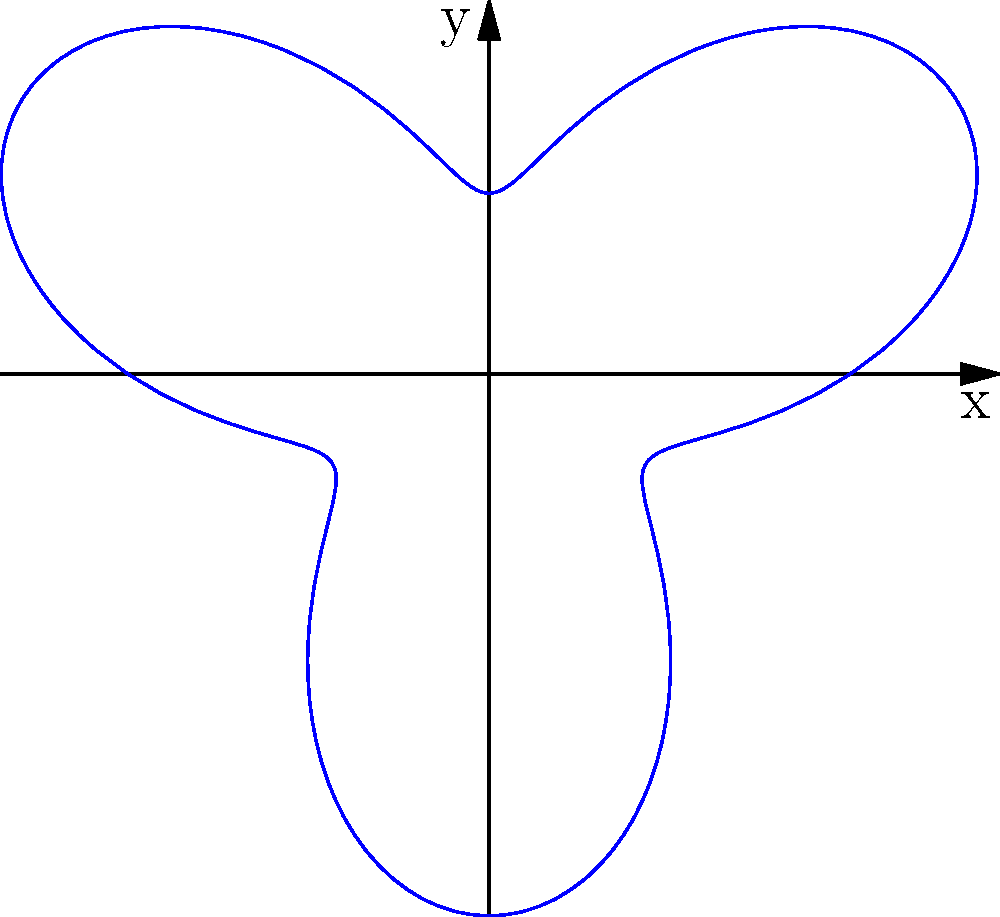As an organic farmer, you're analyzing a new pesticide spray pattern for your crops. The coverage is represented by the polar curve $r = 2 + \sin(3\theta)$. What is the maximum radial distance the spray reaches from the nozzle? To find the maximum radial distance, we need to follow these steps:

1) The given polar curve is $r = 2 + \sin(3\theta)$.

2) The maximum value of sine function is 1, which occurs when its argument is $\frac{\pi}{2}$ or odd multiples of it.

3) So, we need to find when $3\theta = \frac{\pi}{2}$, $\frac{5\pi}{2}$, $\frac{9\pi}{2}$, etc.

4) The first occurrence is when $\theta = \frac{\pi}{6}$.

5) At this point, $\sin(3\theta) = \sin(\frac{\pi}{2}) = 1$.

6) Therefore, the maximum value of $r$ is:

   $r_{max} = 2 + 1 = 3$

7) This means the spray reaches a maximum distance of 3 units from the nozzle.
Answer: 3 units 